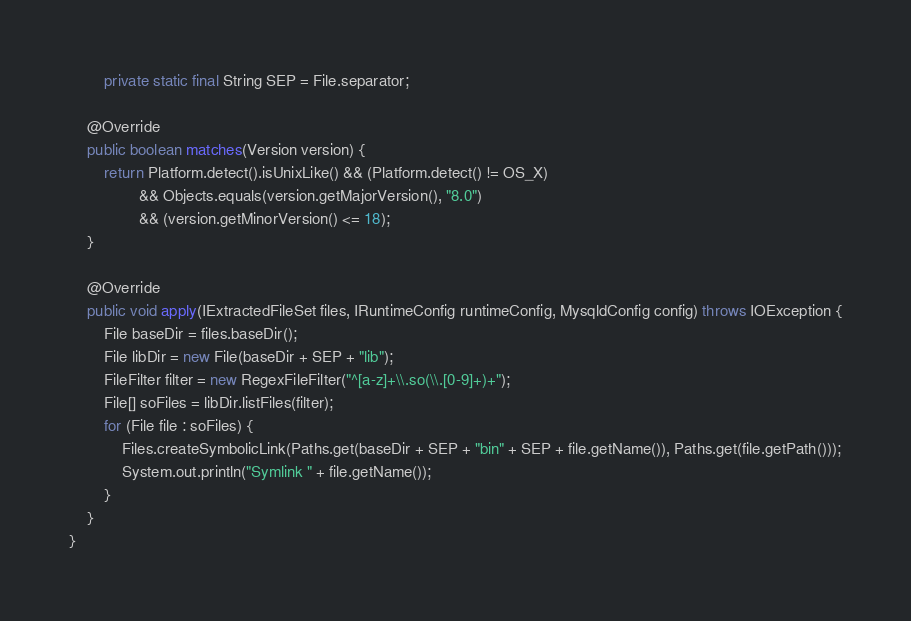<code> <loc_0><loc_0><loc_500><loc_500><_Java_>        private static final String SEP = File.separator;
    
    @Override
    public boolean matches(Version version) {
    	return Platform.detect().isUnixLike() && (Platform.detect() != OS_X)
                && Objects.equals(version.getMajorVersion(), "8.0")
                && (version.getMinorVersion() <= 18);
    }

    @Override
    public void apply(IExtractedFileSet files, IRuntimeConfig runtimeConfig, MysqldConfig config) throws IOException {
        File baseDir = files.baseDir();
        File libDir = new File(baseDir + SEP + "lib");
        FileFilter filter = new RegexFileFilter("^[a-z]+\\.so(\\.[0-9]+)+");
        File[] soFiles = libDir.listFiles(filter);
        for (File file : soFiles) {
            Files.createSymbolicLink(Paths.get(baseDir + SEP + "bin" + SEP + file.getName()), Paths.get(file.getPath()));
            System.out.println("Symlink " + file.getName());
        }
    }
}
</code> 